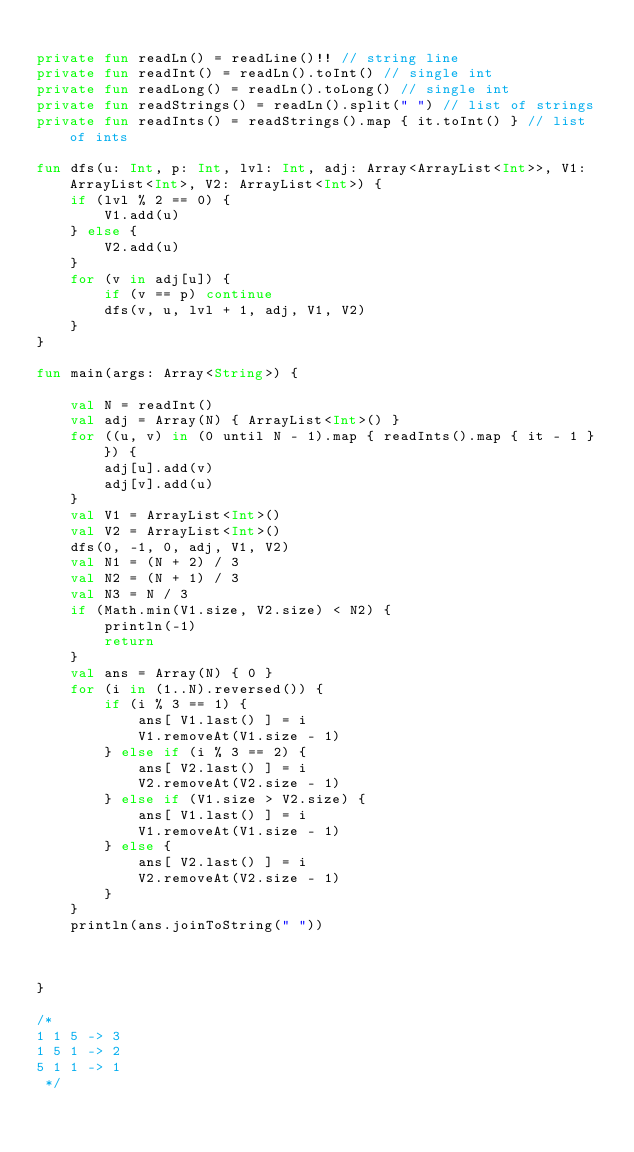<code> <loc_0><loc_0><loc_500><loc_500><_Kotlin_>
private fun readLn() = readLine()!! // string line
private fun readInt() = readLn().toInt() // single int
private fun readLong() = readLn().toLong() // single int
private fun readStrings() = readLn().split(" ") // list of strings
private fun readInts() = readStrings().map { it.toInt() } // list of ints

fun dfs(u: Int, p: Int, lvl: Int, adj: Array<ArrayList<Int>>, V1: ArrayList<Int>, V2: ArrayList<Int>) {
    if (lvl % 2 == 0) {
        V1.add(u)
    } else {
        V2.add(u)
    }
    for (v in adj[u]) {
        if (v == p) continue
        dfs(v, u, lvl + 1, adj, V1, V2)
    }
}

fun main(args: Array<String>) {

    val N = readInt()
    val adj = Array(N) { ArrayList<Int>() }
    for ((u, v) in (0 until N - 1).map { readInts().map { it - 1 } }) {
        adj[u].add(v)
        adj[v].add(u)
    }
    val V1 = ArrayList<Int>()
    val V2 = ArrayList<Int>()
    dfs(0, -1, 0, adj, V1, V2)
    val N1 = (N + 2) / 3
    val N2 = (N + 1) / 3
    val N3 = N / 3
    if (Math.min(V1.size, V2.size) < N2) {
        println(-1)
        return
    }
    val ans = Array(N) { 0 }
    for (i in (1..N).reversed()) {
        if (i % 3 == 1) {
            ans[ V1.last() ] = i
            V1.removeAt(V1.size - 1)
        } else if (i % 3 == 2) {
            ans[ V2.last() ] = i
            V2.removeAt(V2.size - 1)
        } else if (V1.size > V2.size) {
            ans[ V1.last() ] = i
            V1.removeAt(V1.size - 1)
        } else {
            ans[ V2.last() ] = i
            V2.removeAt(V2.size - 1)
        }
    }
    println(ans.joinToString(" "))



}

/*
1 1 5 -> 3
1 5 1 -> 2
5 1 1 -> 1
 */
</code> 